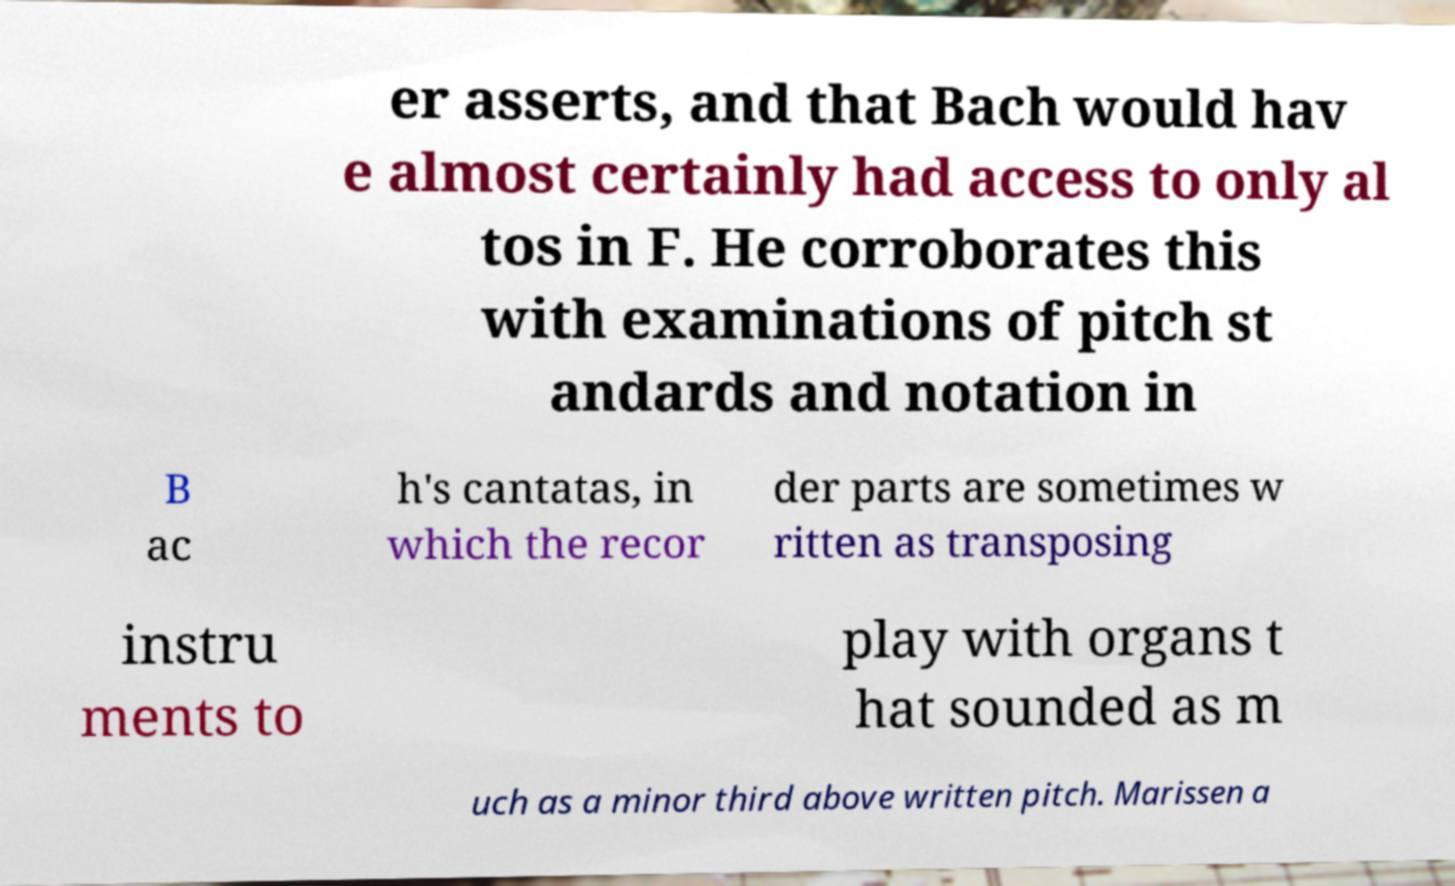I need the written content from this picture converted into text. Can you do that? er asserts, and that Bach would hav e almost certainly had access to only al tos in F. He corroborates this with examinations of pitch st andards and notation in B ac h's cantatas, in which the recor der parts are sometimes w ritten as transposing instru ments to play with organs t hat sounded as m uch as a minor third above written pitch. Marissen a 